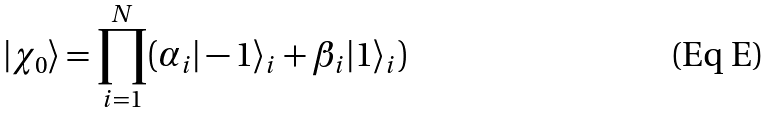Convert formula to latex. <formula><loc_0><loc_0><loc_500><loc_500>| \chi _ { 0 } \rangle = \prod _ { i = 1 } ^ { N } ( \alpha _ { i } | - 1 \rangle _ { i } + \beta _ { i } | 1 \rangle _ { i } )</formula> 